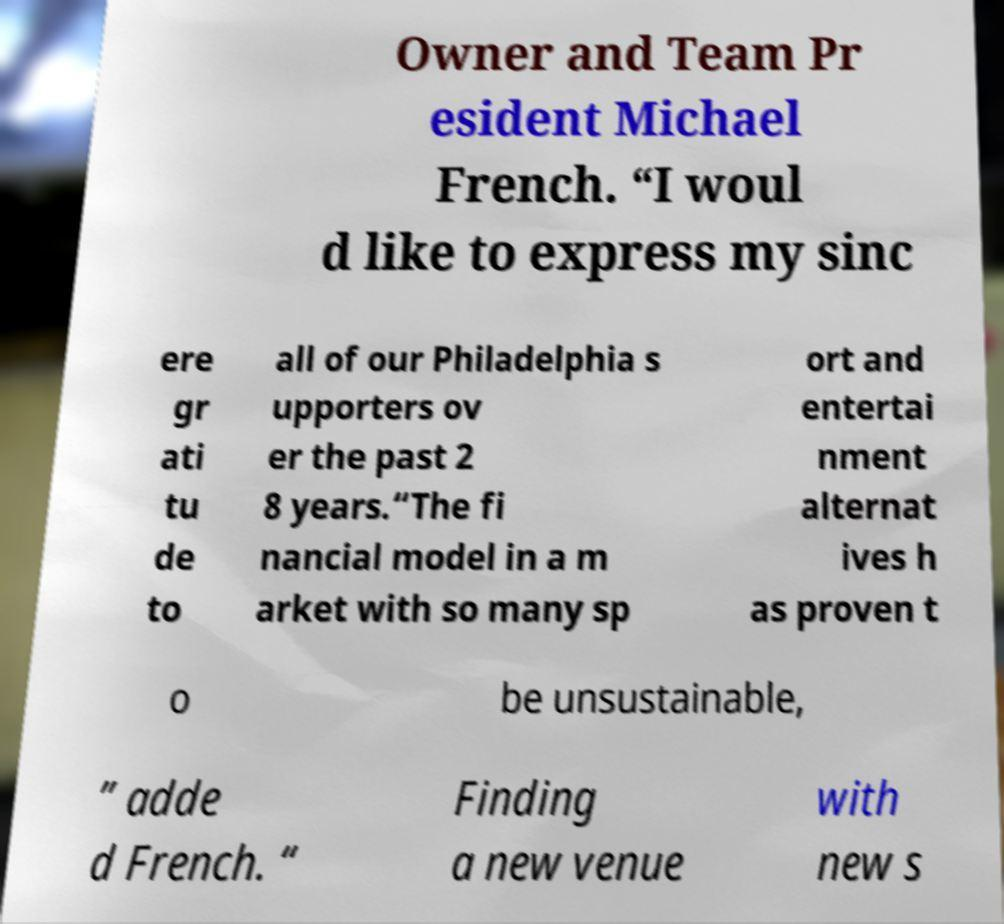There's text embedded in this image that I need extracted. Can you transcribe it verbatim? Owner and Team Pr esident Michael French. “I woul d like to express my sinc ere gr ati tu de to all of our Philadelphia s upporters ov er the past 2 8 years.“The fi nancial model in a m arket with so many sp ort and entertai nment alternat ives h as proven t o be unsustainable, ” adde d French. “ Finding a new venue with new s 